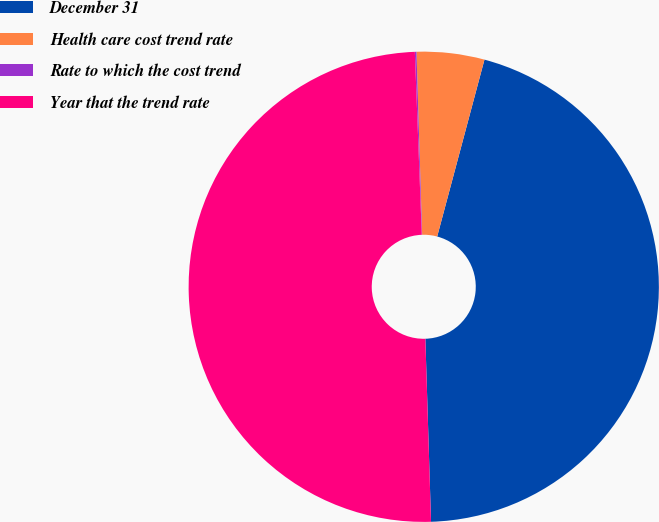Convert chart. <chart><loc_0><loc_0><loc_500><loc_500><pie_chart><fcel>December 31<fcel>Health care cost trend rate<fcel>Rate to which the cost trend<fcel>Year that the trend rate<nl><fcel>45.35%<fcel>4.65%<fcel>0.11%<fcel>49.89%<nl></chart> 